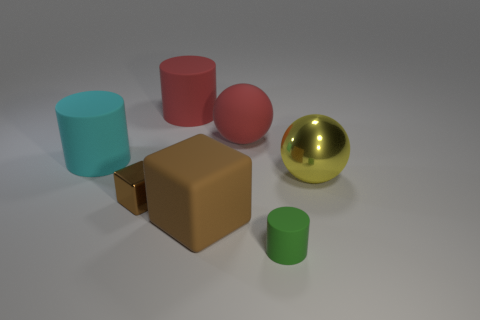Add 1 big blue metallic things. How many objects exist? 8 Subtract all small green cylinders. How many cylinders are left? 2 Subtract all cyan cylinders. How many cylinders are left? 2 Subtract 0 gray cylinders. How many objects are left? 7 Subtract all blocks. How many objects are left? 5 Subtract 3 cylinders. How many cylinders are left? 0 Subtract all red balls. Subtract all red cubes. How many balls are left? 1 Subtract all purple cylinders. How many yellow balls are left? 1 Subtract all red cylinders. Subtract all large matte balls. How many objects are left? 5 Add 7 cubes. How many cubes are left? 9 